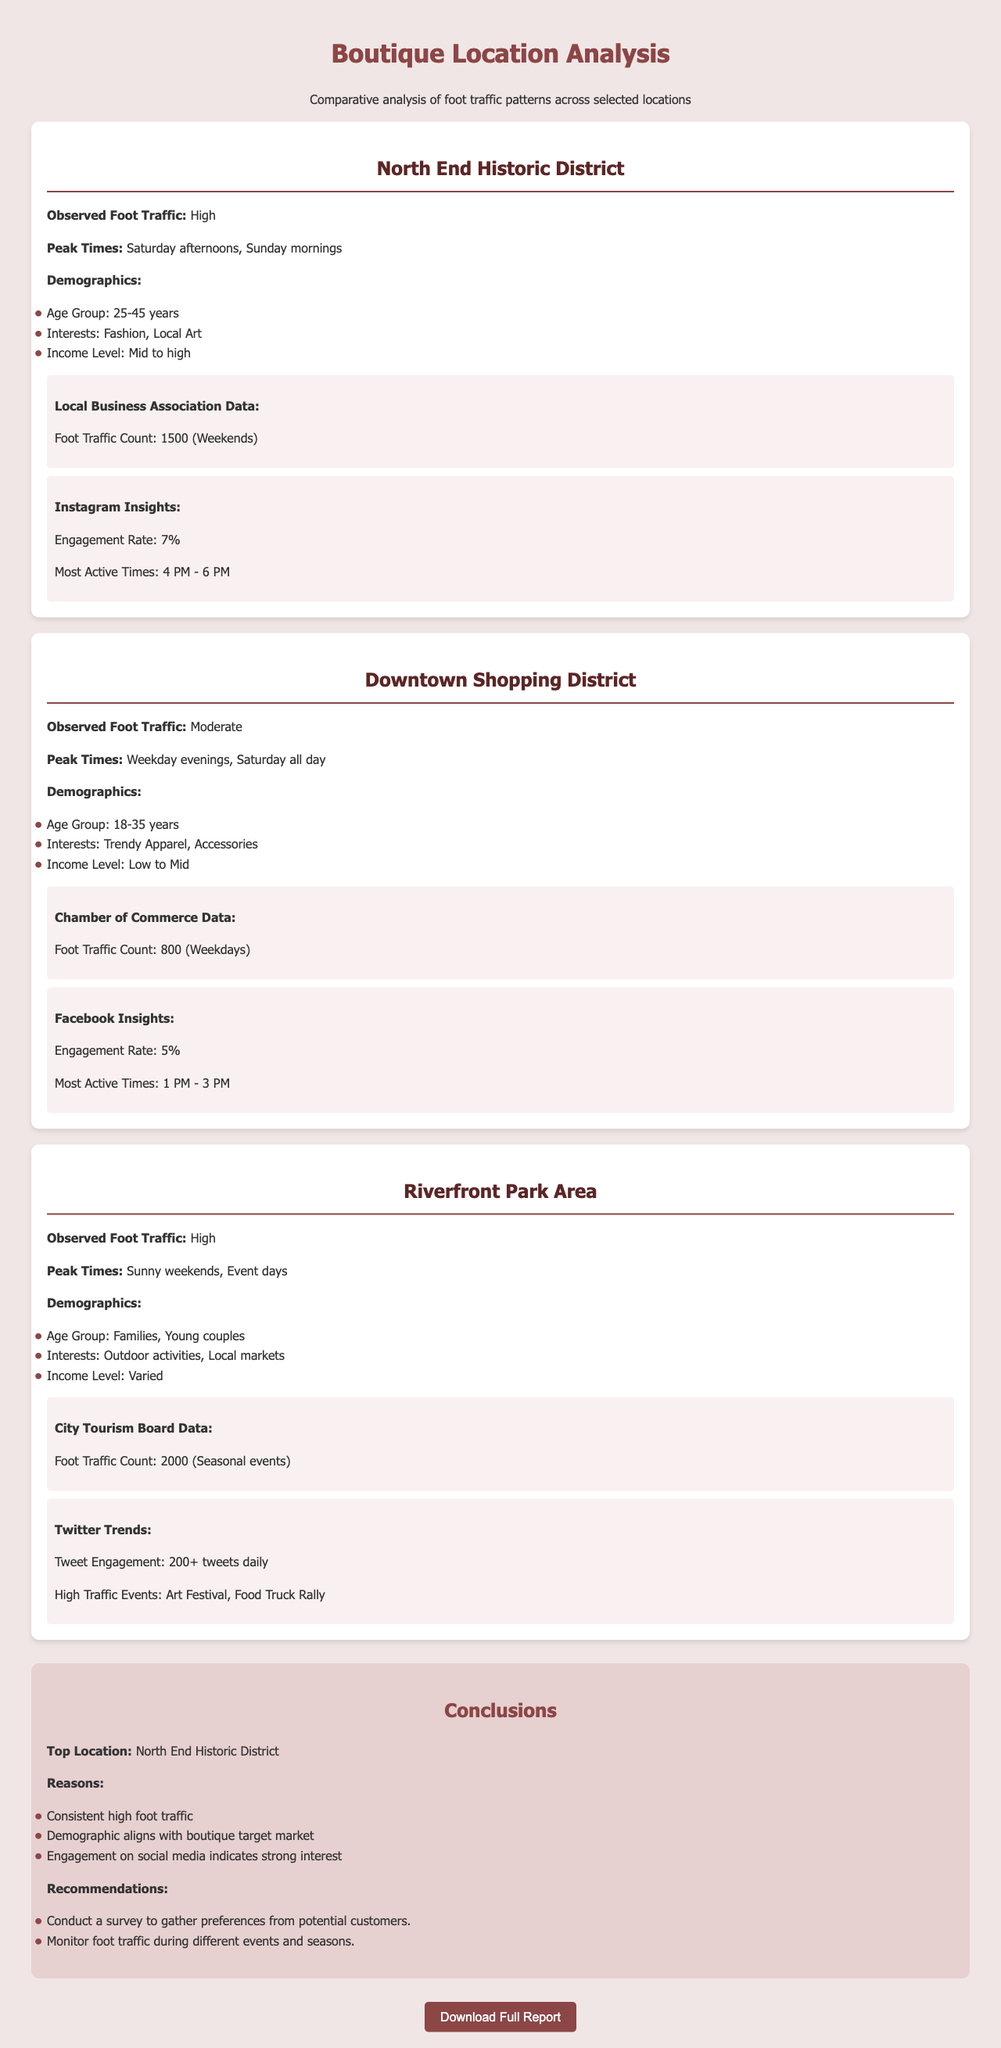What is the observed foot traffic in the North End Historic District? The North End Historic District has an observed foot traffic of high as stated in the document.
Answer: High What are the peak times for foot traffic in the Downtown Shopping District? The peak times for foot traffic in the Downtown Shopping District are listed in the document as weekday evenings and Saturday all day.
Answer: Weekday evenings, Saturday all day What is the engagement rate for Riverfront Park Area based on Twitter Trends? The document mentions the tweet engagement for Riverfront Park Area as 200+ tweets daily.
Answer: 200+ tweets daily Which location has the highest foot traffic count during weekends? The foot traffic count for weekends is highlighted in the document with Riverfront Park Area having the highest with 2000.
Answer: 2000 What demographics are associated with the North End Historic District? The demographics associated with North End Historic District include age group 25-45 years, which is included in the document.
Answer: Age Group: 25-45 years What is the conclusion about the top location for opening a boutique? The document emphasizes that the top location for opening a boutique is the North End Historic District.
Answer: North End Historic District Which location has the lowest observed foot traffic? The observed foot traffic in the Downtown Shopping District is referred to as moderate, indicating it is the lowest among the three locations.
Answer: Moderate What recommendations are made for gathering customer preferences? The document recommends conducting a survey to gather preferences from potential customers.
Answer: Conduct a survey to gather preferences from potential customers 